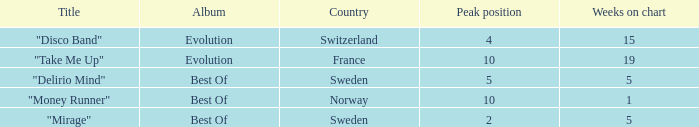What is the title of the single with the peak position of 10 and weeks on chart is less than 19? "Money Runner". 